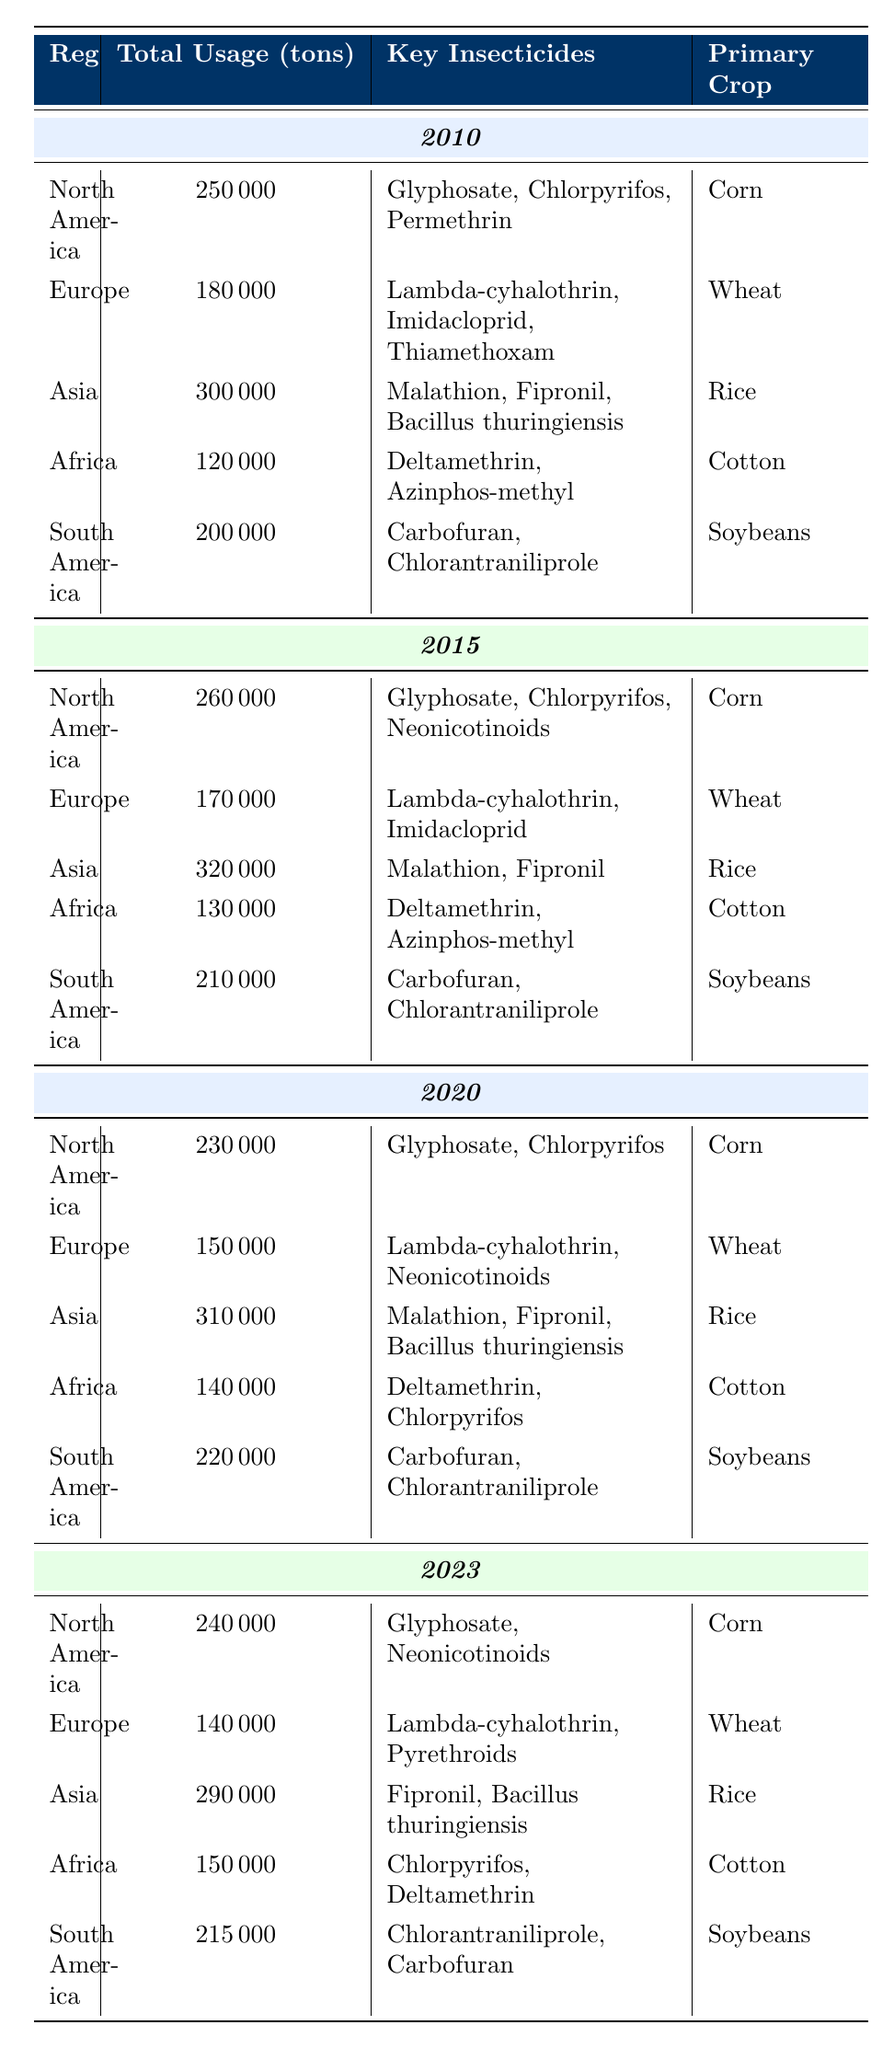What was the total insecticide usage in North America in 2010? The table shows that for the year 2010, the total insecticide usage in North America was listed as 250000 tons.
Answer: 250000 tons Which region had the highest insecticide usage in 2015? By comparing the total usage across all regions in 2015, Asia had the highest usage at 320000 tons.
Answer: Asia What are the key insecticides used in Europe in 2020? The table indicates that the key insecticides used in Europe in 2020 were Lambda-cyhalothrin and Neonicotinoids.
Answer: Lambda-cyhalothrin, Neonicotinoids How much more insecticide was used in South America in 2020 compared to 2010? To find the difference, we subtract 2010 usage (200000 tons) from 2020 usage (220000 tons) resulting in 220000 - 200000 = 20000 tons more in 2020.
Answer: 20000 tons Did total insecticide usage in Europe increase from 2010 to 2023? The total usage in Europe was 180000 tons in 2010 and decreased to 140000 tons in 2023, indicating a decline.
Answer: No What is the average insecticide usage across all regions in 2023? The total usage in 2023 for all regions is 240000 + 140000 + 290000 + 150000 + 215000 = 1035000 tons, then divide by 5 regions, so the average is 1035000 / 5 = 207000 tons.
Answer: 207000 tons Which key insecticide is common to both North America in 2010 and 2023? The table shows that Glyphosate was used in North America in both 2010 and 2023.
Answer: Glyphosate How much did the total insecticide usage in Africa change from 2015 to 2023? The total usage in Africa for 2015 was 130000 tons, and in 2023 it was 150000 tons, indicating an increase of 150000 - 130000 = 20000 tons.
Answer: 20000 tons What was the primary crop for Africa in 2010? According to the table, the primary crop for Africa in 2010 was Cotton.
Answer: Cotton How does the key insecticide usage in South America change between 2015 and 2023? South America used Carbofuran and Chlorantraniliprole in 2015, but in 2023, the key insecticides shifted to Chlorantraniliprole and Carbofuran, indicating no change in the key insecticides but potentially in their order or importance.
Answer: No change in key insecticides Which region shows a consistent primary crop across all years? The table reveals that North America consistently has Corn as the primary crop across the years 2010, 2015, 2020, and 2023.
Answer: North America (Corn) 